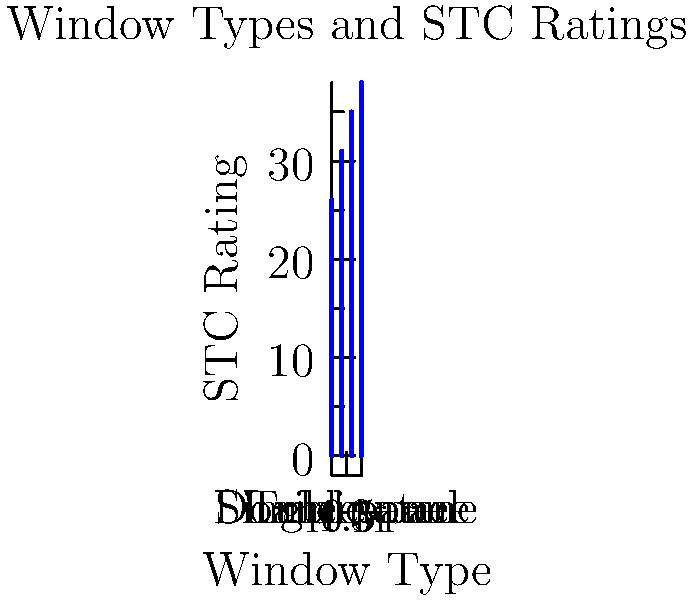Based on the graph showing STC ratings for different window types, calculate the average improvement in STC rating when upgrading from single-pane to triple-pane windows. How much additional noise reduction (in decibels) can the homeowner expect? To solve this problem, we'll follow these steps:

1. Identify the STC ratings:
   Single-pane: 26
   Triple-pane: 38

2. Calculate the difference in STC ratings:
   $$ \text{Difference} = \text{STC}_{\text{triple-pane}} - \text{STC}_{\text{single-pane}} $$
   $$ \text{Difference} = 38 - 26 = 12 $$

3. Interpret the STC difference:
   Each point in the STC scale represents a reduction of 1 decibel in sound transmission.

Therefore, upgrading from single-pane to triple-pane windows will result in an average improvement of 12 STC points, which translates to a 12 decibel reduction in sound transmission.
Answer: 12 decibels 